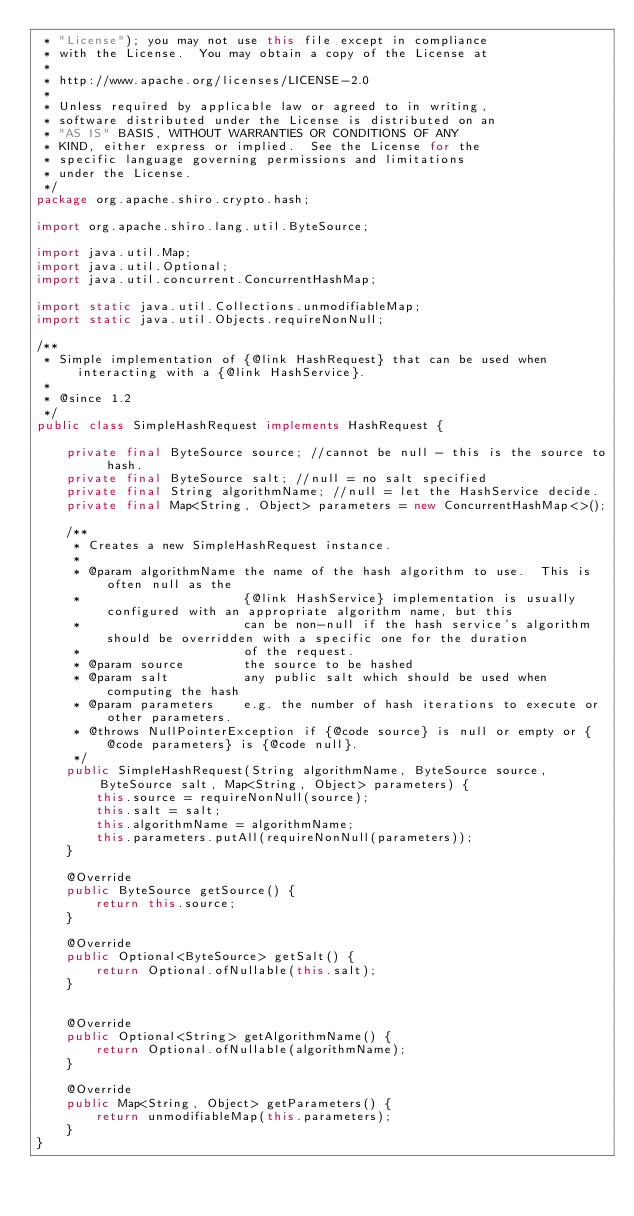Convert code to text. <code><loc_0><loc_0><loc_500><loc_500><_Java_> * "License"); you may not use this file except in compliance
 * with the License.  You may obtain a copy of the License at
 *
 * http://www.apache.org/licenses/LICENSE-2.0
 *
 * Unless required by applicable law or agreed to in writing,
 * software distributed under the License is distributed on an
 * "AS IS" BASIS, WITHOUT WARRANTIES OR CONDITIONS OF ANY
 * KIND, either express or implied.  See the License for the
 * specific language governing permissions and limitations
 * under the License.
 */
package org.apache.shiro.crypto.hash;

import org.apache.shiro.lang.util.ByteSource;

import java.util.Map;
import java.util.Optional;
import java.util.concurrent.ConcurrentHashMap;

import static java.util.Collections.unmodifiableMap;
import static java.util.Objects.requireNonNull;

/**
 * Simple implementation of {@link HashRequest} that can be used when interacting with a {@link HashService}.
 *
 * @since 1.2
 */
public class SimpleHashRequest implements HashRequest {

    private final ByteSource source; //cannot be null - this is the source to hash.
    private final ByteSource salt; //null = no salt specified
    private final String algorithmName; //null = let the HashService decide.
    private final Map<String, Object> parameters = new ConcurrentHashMap<>();

    /**
     * Creates a new SimpleHashRequest instance.
     *
     * @param algorithmName the name of the hash algorithm to use.  This is often null as the
     *                      {@link HashService} implementation is usually configured with an appropriate algorithm name, but this
     *                      can be non-null if the hash service's algorithm should be overridden with a specific one for the duration
     *                      of the request.
     * @param source        the source to be hashed
     * @param salt          any public salt which should be used when computing the hash
     * @param parameters    e.g. the number of hash iterations to execute or other parameters.
     * @throws NullPointerException if {@code source} is null or empty or {@code parameters} is {@code null}.
     */
    public SimpleHashRequest(String algorithmName, ByteSource source, ByteSource salt, Map<String, Object> parameters) {
        this.source = requireNonNull(source);
        this.salt = salt;
        this.algorithmName = algorithmName;
        this.parameters.putAll(requireNonNull(parameters));
    }

    @Override
    public ByteSource getSource() {
        return this.source;
    }

    @Override
    public Optional<ByteSource> getSalt() {
        return Optional.ofNullable(this.salt);
    }


    @Override
    public Optional<String> getAlgorithmName() {
        return Optional.ofNullable(algorithmName);
    }

    @Override
    public Map<String, Object> getParameters() {
        return unmodifiableMap(this.parameters);
    }
}
</code> 